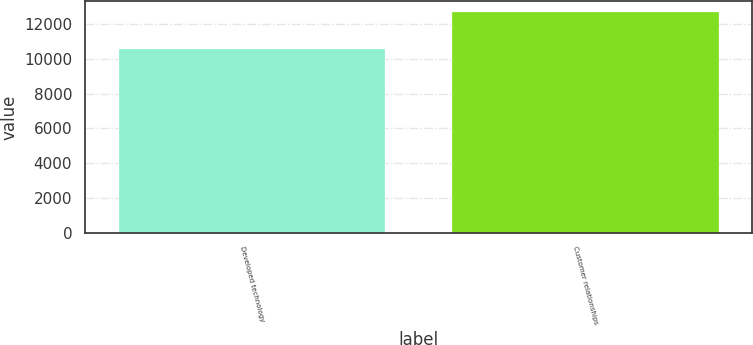Convert chart to OTSL. <chart><loc_0><loc_0><loc_500><loc_500><bar_chart><fcel>Developed technology<fcel>Customer relationships<nl><fcel>10550<fcel>12700<nl></chart> 